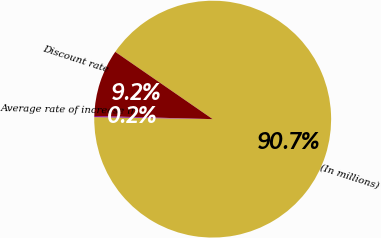Convert chart. <chart><loc_0><loc_0><loc_500><loc_500><pie_chart><fcel>(In millions)<fcel>Discount rate<fcel>Average rate of increase in<nl><fcel>90.65%<fcel>9.2%<fcel>0.15%<nl></chart> 